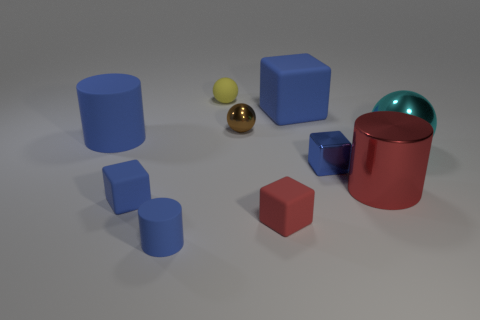The matte block that is the same color as the big shiny cylinder is what size? The matte block sharing the same color as the large glossy cylinder appears to be medium-sized compared to the other objects present. 